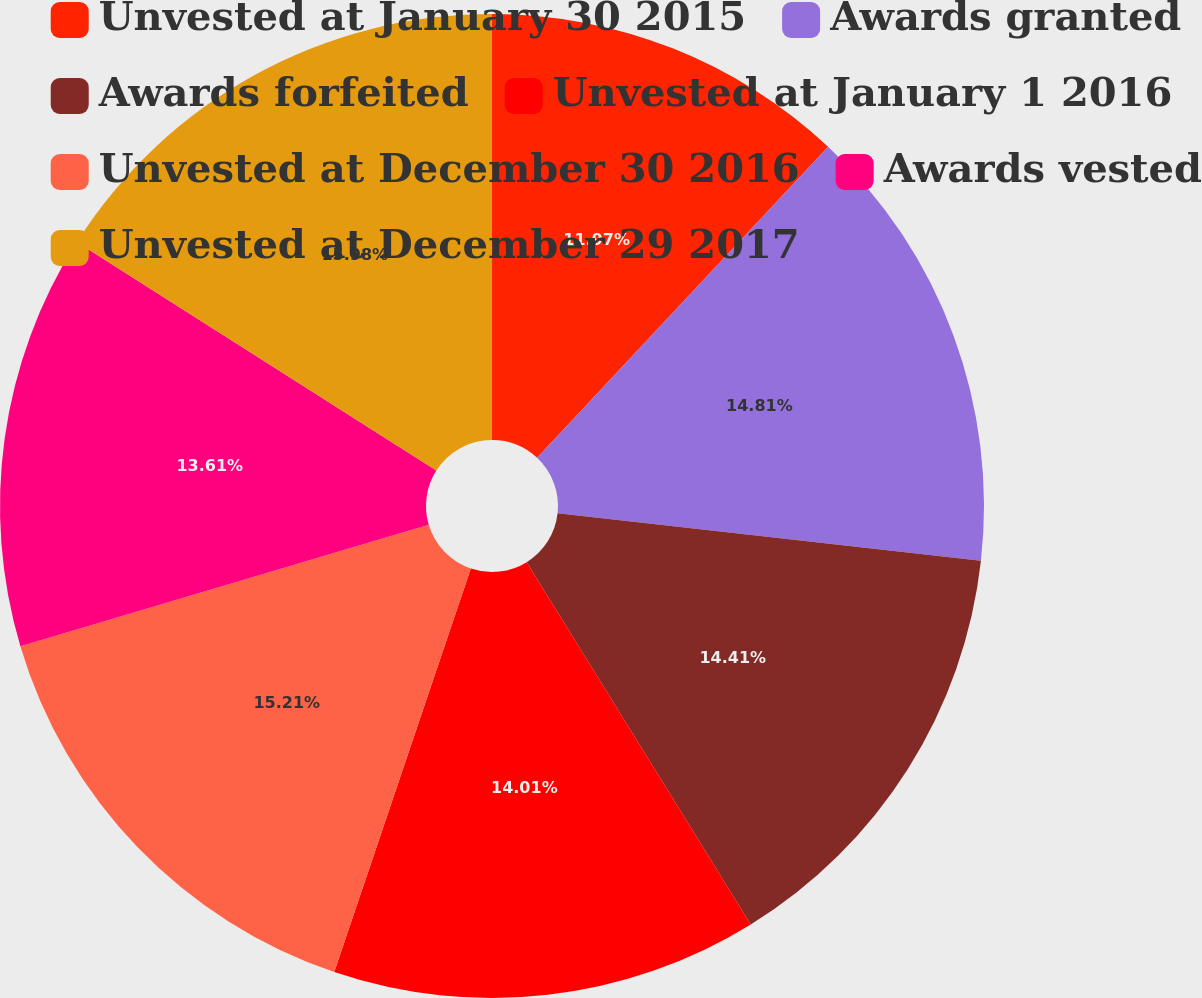Convert chart to OTSL. <chart><loc_0><loc_0><loc_500><loc_500><pie_chart><fcel>Unvested at January 30 2015<fcel>Awards granted<fcel>Awards forfeited<fcel>Unvested at January 1 2016<fcel>Unvested at December 30 2016<fcel>Awards vested<fcel>Unvested at December 29 2017<nl><fcel>11.97%<fcel>14.81%<fcel>14.41%<fcel>14.01%<fcel>15.21%<fcel>13.61%<fcel>15.99%<nl></chart> 